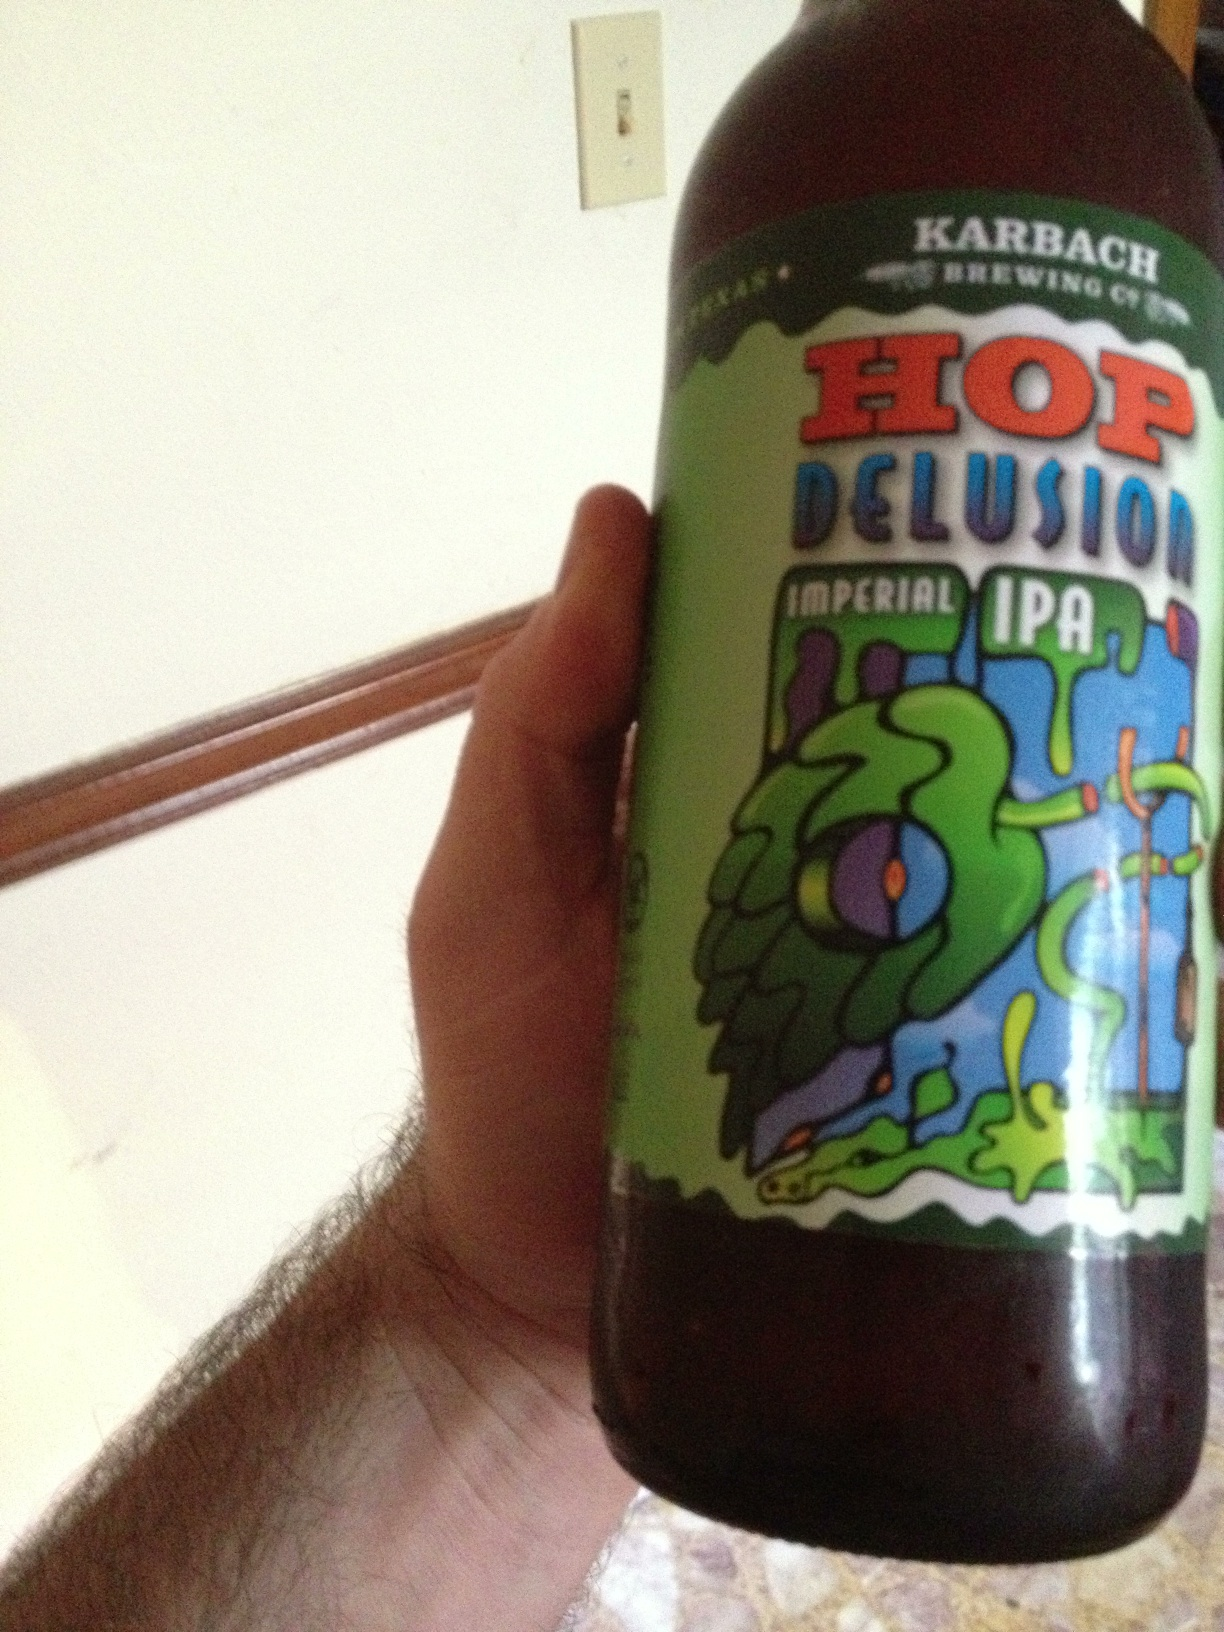Describe a perfect setting to enjoy this beer. A perfect setting to enjoy Hop Delusion Imperial IPA would be at a cozy outdoor barbecue with friends. The sun is setting, casting a warm glow over everything, and the air is filled with the delicious aroma of grilled meats. Laughter and good conversation flow freely, making it an ideal moment to savor the bold and refreshing notes of this fantastic beer. 